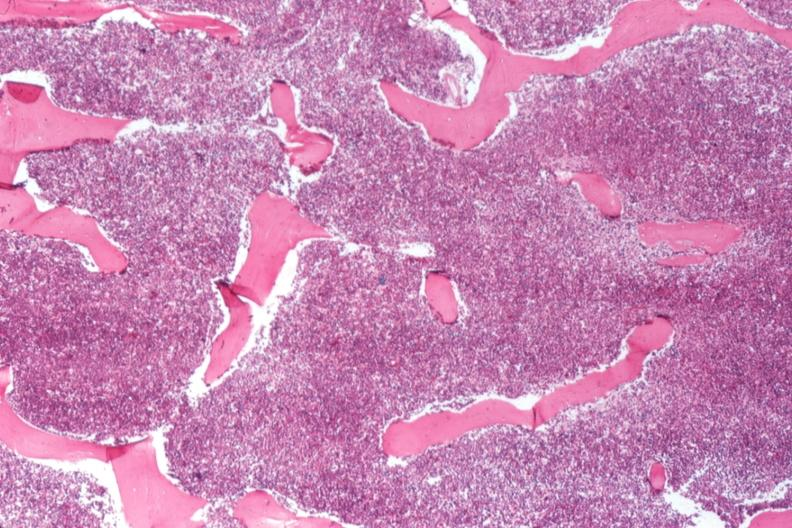what is present?
Answer the question using a single word or phrase. Chronic myelogenous leukemia 